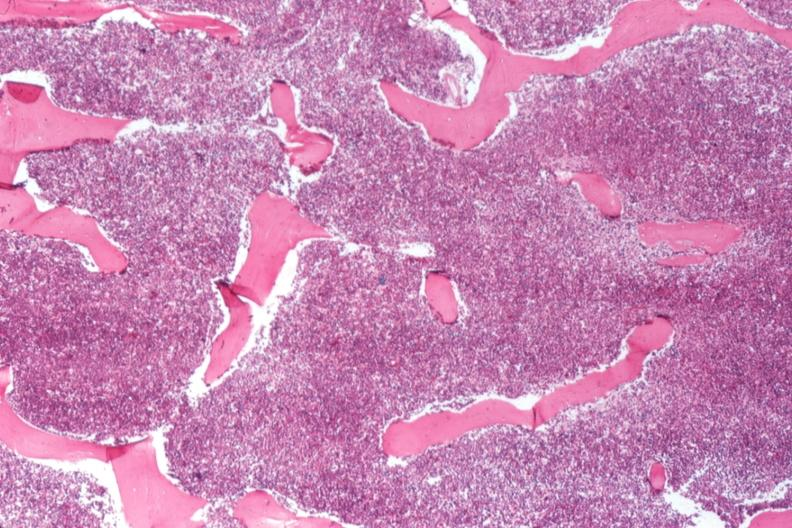what is present?
Answer the question using a single word or phrase. Chronic myelogenous leukemia 